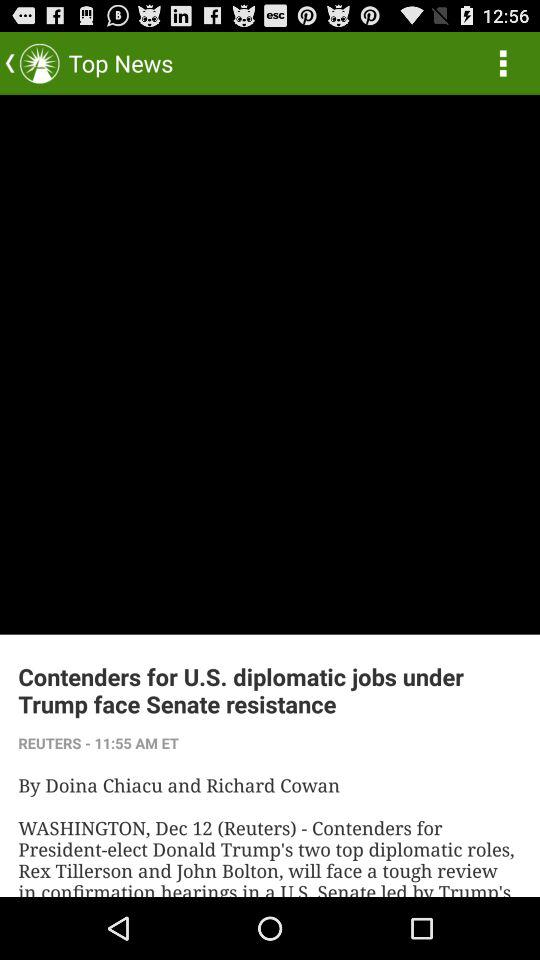Where was the article published? The article was published in Washington. 